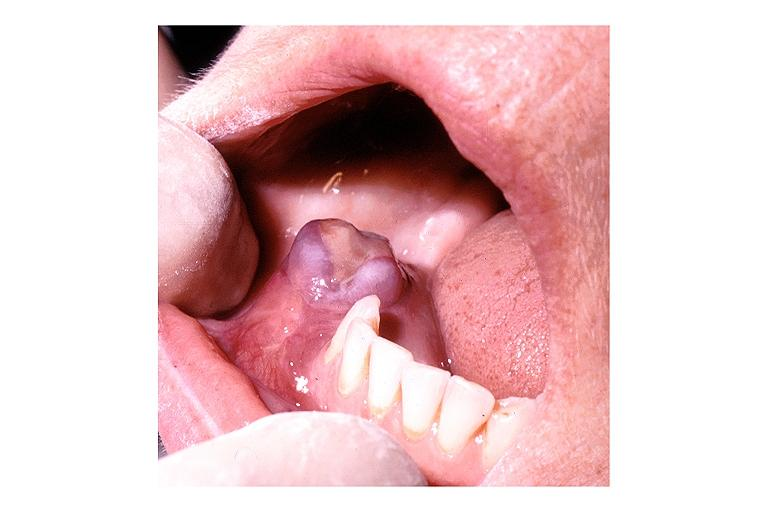s female reproductive present?
Answer the question using a single word or phrase. No 